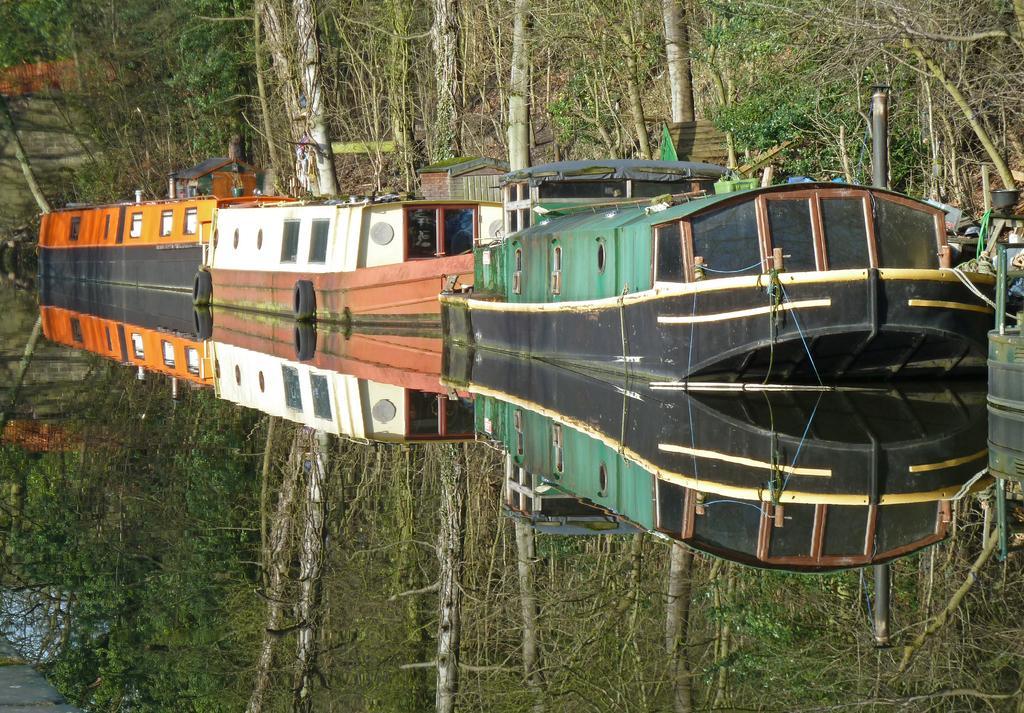Describe this image in one or two sentences. In this picture, we can see boats, trees, stairs, ground and the reflection of trees in the water and we can see some objects on the right. 